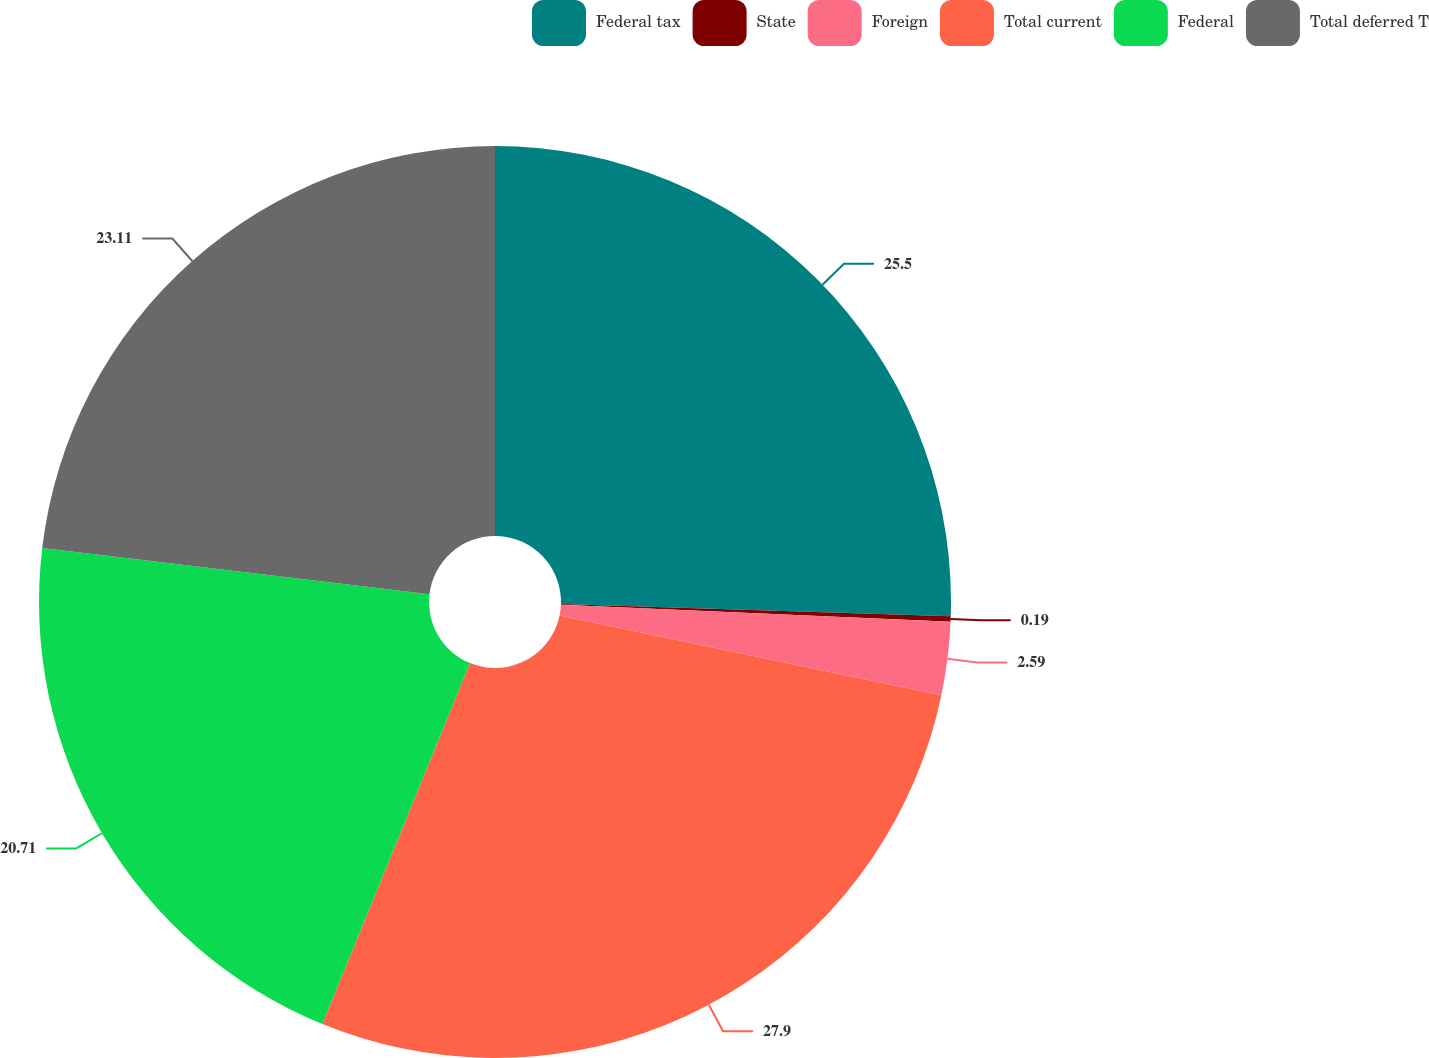<chart> <loc_0><loc_0><loc_500><loc_500><pie_chart><fcel>Federal tax<fcel>State<fcel>Foreign<fcel>Total current<fcel>Federal<fcel>Total deferred T<nl><fcel>25.5%<fcel>0.19%<fcel>2.59%<fcel>27.9%<fcel>20.71%<fcel>23.11%<nl></chart> 